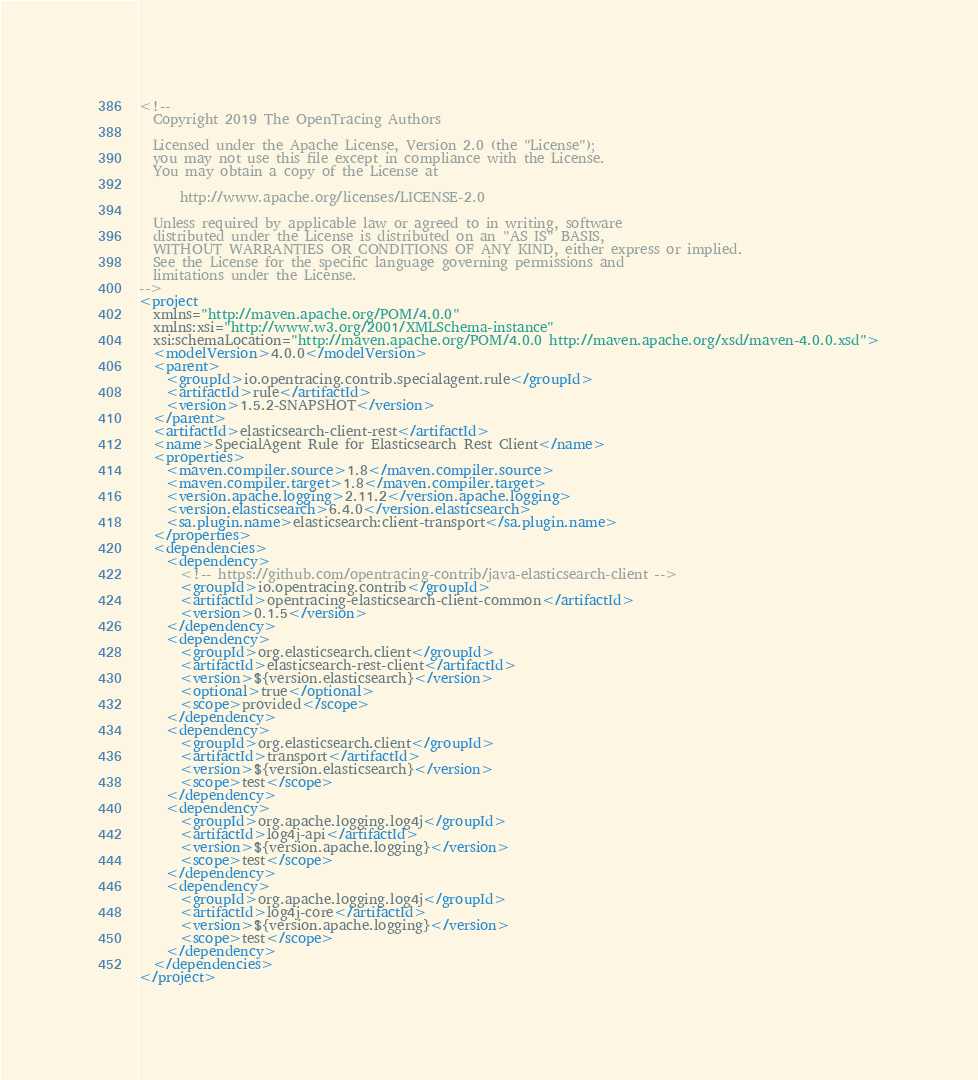Convert code to text. <code><loc_0><loc_0><loc_500><loc_500><_XML_><!--
  Copyright 2019 The OpenTracing Authors

  Licensed under the Apache License, Version 2.0 (the "License");
  you may not use this file except in compliance with the License.
  You may obtain a copy of the License at

      http://www.apache.org/licenses/LICENSE-2.0

  Unless required by applicable law or agreed to in writing, software
  distributed under the License is distributed on an "AS IS" BASIS,
  WITHOUT WARRANTIES OR CONDITIONS OF ANY KIND, either express or implied.
  See the License for the specific language governing permissions and
  limitations under the License.
-->
<project
  xmlns="http://maven.apache.org/POM/4.0.0"
  xmlns:xsi="http://www.w3.org/2001/XMLSchema-instance"
  xsi:schemaLocation="http://maven.apache.org/POM/4.0.0 http://maven.apache.org/xsd/maven-4.0.0.xsd">
  <modelVersion>4.0.0</modelVersion>
  <parent>
    <groupId>io.opentracing.contrib.specialagent.rule</groupId>
    <artifactId>rule</artifactId>
    <version>1.5.2-SNAPSHOT</version>
  </parent>
  <artifactId>elasticsearch-client-rest</artifactId>
  <name>SpecialAgent Rule for Elasticsearch Rest Client</name>
  <properties>
    <maven.compiler.source>1.8</maven.compiler.source>
    <maven.compiler.target>1.8</maven.compiler.target>
    <version.apache.logging>2.11.2</version.apache.logging>
    <version.elasticsearch>6.4.0</version.elasticsearch>
    <sa.plugin.name>elasticsearch:client-transport</sa.plugin.name>
  </properties>
  <dependencies>
    <dependency>
      <!-- https://github.com/opentracing-contrib/java-elasticsearch-client -->
      <groupId>io.opentracing.contrib</groupId>
      <artifactId>opentracing-elasticsearch-client-common</artifactId>
      <version>0.1.5</version>
    </dependency>
    <dependency>
      <groupId>org.elasticsearch.client</groupId>
      <artifactId>elasticsearch-rest-client</artifactId>
      <version>${version.elasticsearch}</version>
      <optional>true</optional>
      <scope>provided</scope>
    </dependency>
    <dependency>
      <groupId>org.elasticsearch.client</groupId>
      <artifactId>transport</artifactId>
      <version>${version.elasticsearch}</version>
      <scope>test</scope>
    </dependency>
    <dependency>
      <groupId>org.apache.logging.log4j</groupId>
      <artifactId>log4j-api</artifactId>
      <version>${version.apache.logging}</version>
      <scope>test</scope>
    </dependency>
    <dependency>
      <groupId>org.apache.logging.log4j</groupId>
      <artifactId>log4j-core</artifactId>
      <version>${version.apache.logging}</version>
      <scope>test</scope>
    </dependency>
  </dependencies>
</project></code> 